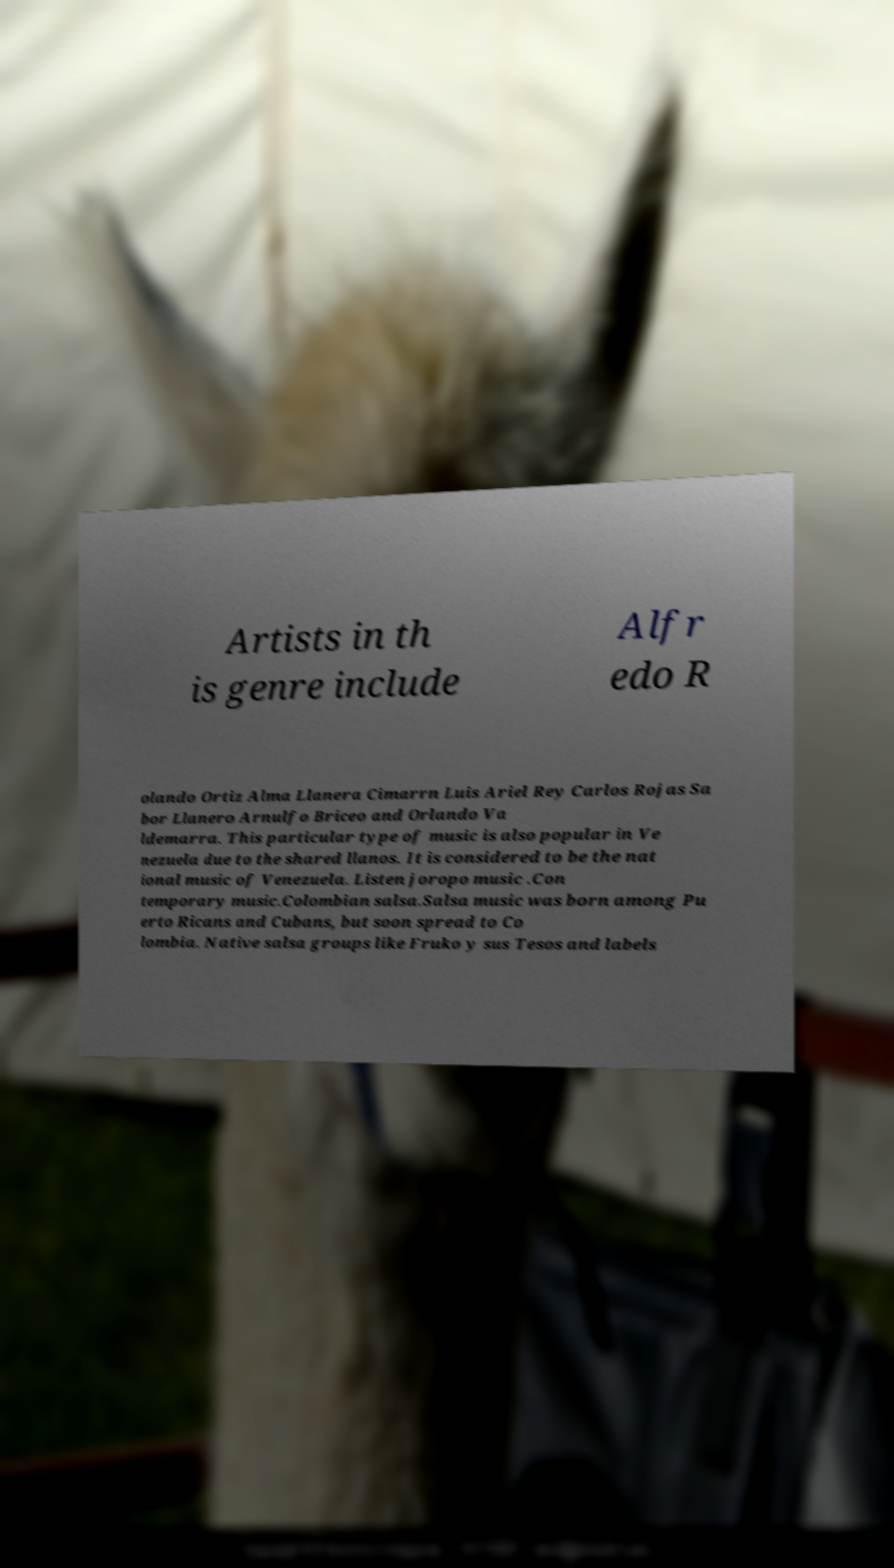For documentation purposes, I need the text within this image transcribed. Could you provide that? Artists in th is genre include Alfr edo R olando Ortiz Alma Llanera Cimarrn Luis Ariel Rey Carlos Rojas Sa bor Llanero Arnulfo Briceo and Orlando Va ldemarra. This particular type of music is also popular in Ve nezuela due to the shared llanos. It is considered to be the nat ional music of Venezuela. Listen joropo music .Con temporary music.Colombian salsa.Salsa music was born among Pu erto Ricans and Cubans, but soon spread to Co lombia. Native salsa groups like Fruko y sus Tesos and labels 